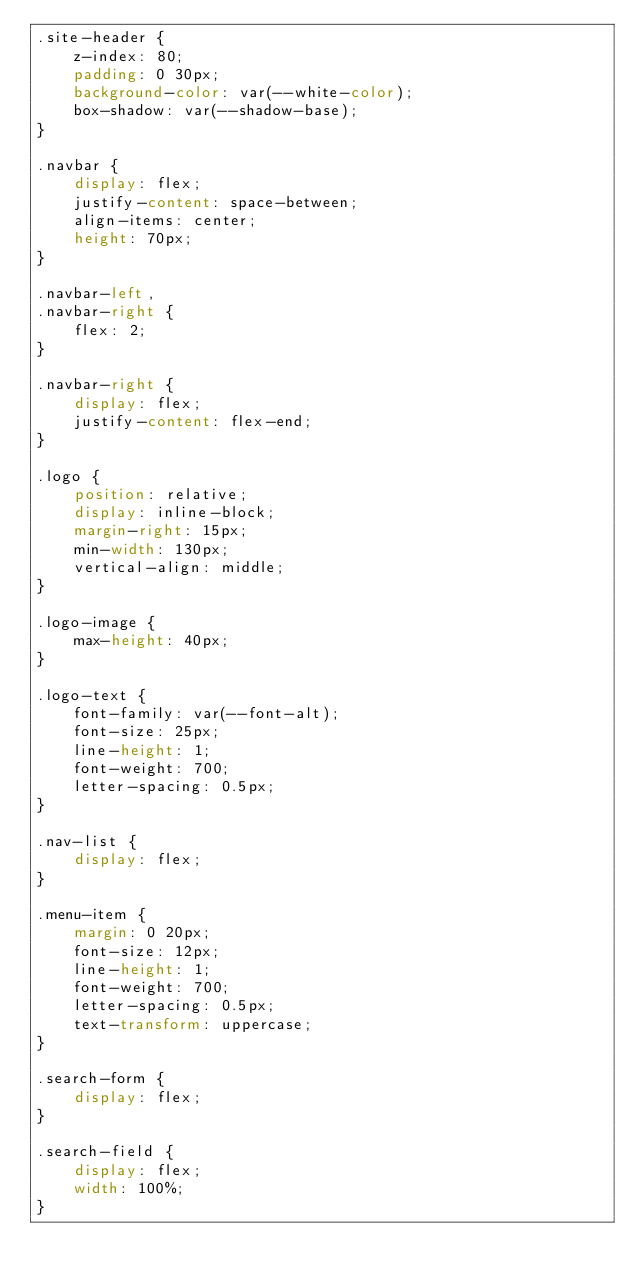<code> <loc_0><loc_0><loc_500><loc_500><_CSS_>.site-header {
    z-index: 80;
    padding: 0 30px;
    background-color: var(--white-color);
    box-shadow: var(--shadow-base);
}

.navbar {
    display: flex;
    justify-content: space-between;
    align-items: center;
    height: 70px;
}

.navbar-left,
.navbar-right {
    flex: 2;
}

.navbar-right {
    display: flex;
    justify-content: flex-end;
}

.logo {
    position: relative;
    display: inline-block;
    margin-right: 15px;
    min-width: 130px;
    vertical-align: middle;
}

.logo-image {
    max-height: 40px;
}

.logo-text {
    font-family: var(--font-alt);
    font-size: 25px;
    line-height: 1;
    font-weight: 700;
    letter-spacing: 0.5px;
}

.nav-list {
    display: flex;
}

.menu-item {
    margin: 0 20px;
    font-size: 12px;
    line-height: 1;
    font-weight: 700;
    letter-spacing: 0.5px;
    text-transform: uppercase;
}

.search-form {
    display: flex;
}

.search-field {
    display: flex;
    width: 100%;
}
</code> 